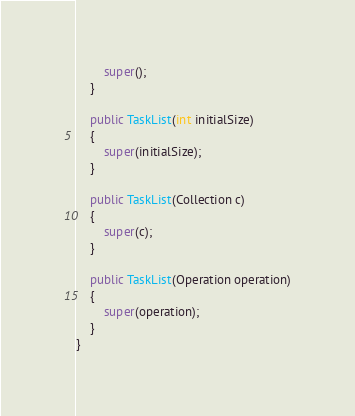<code> <loc_0><loc_0><loc_500><loc_500><_Java_>		super();
	}

	public TaskList(int initialSize)
	{
		super(initialSize);
	}

	public TaskList(Collection c)
	{
		super(c);
	}

	public TaskList(Operation operation)
	{
		super(operation);
	}
}
</code> 